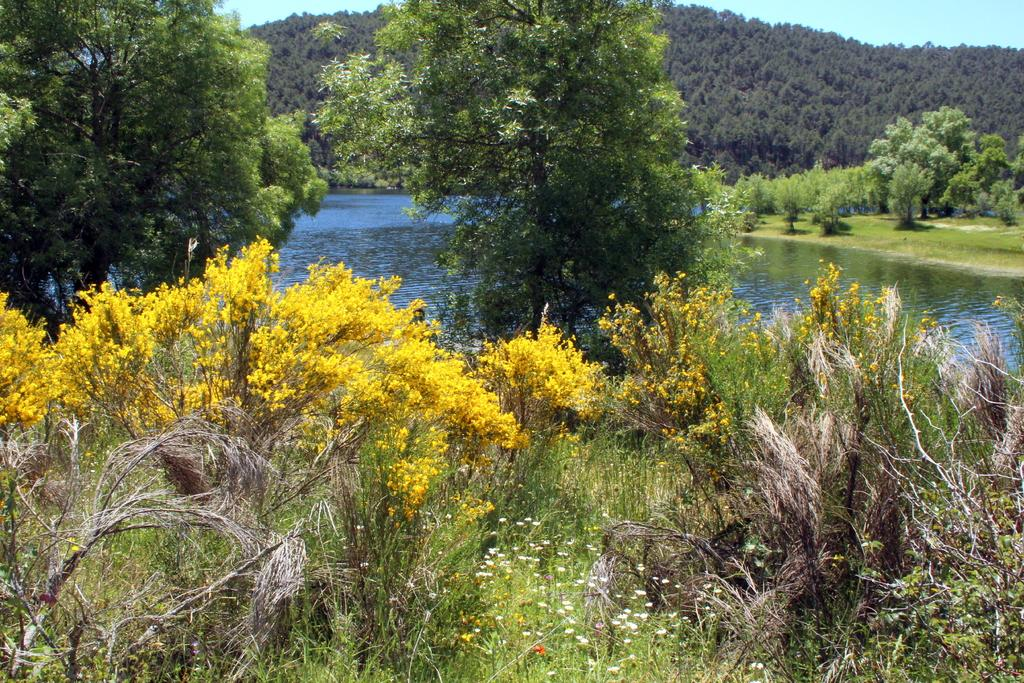What type of vegetation can be seen in the image? There are trees, plants, and flowers visible in the image. What can be seen in the background of the image? The background of the image includes water, grass, trees, a hill, and the sky. How many types of vegetation are present in the image? There are three types of vegetation present in the image: trees, plants, and flowers. What type of apparel is the tree wearing in the image? Trees do not wear apparel, so this question cannot be answered. 